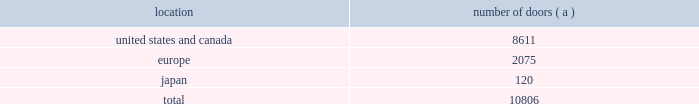Global brand concepts american living american living is the first brand developed under the newglobal brand concepts group .
American living is a full lifestyle brand , featuring menswear , womenswear , childrenswear , accessories and home furnishings with a focus on timeless , authentic american classics for every day .
American living is available exclusively at jcpenney in the u.s .
And online at jcp.com .
Our wholesale segment our wholesale segment sells our products to leading upscale and certain mid-tier department stores , specialty stores and golf and pro shops , both domestically and internationally .
We have focused on elevating our brand and improving productivity by reducing the number of unproductive doors within department stores in which our products are sold , improving in-store product assortment and presentation , and improving full-price sell-throughs to consumers .
As of march 29 , 2008 , the end of fiscal 2008 , our products were sold through 10806 doors worldwide , and during fiscal 2008 , we invested approximately $ 49 million in shop-within-shops dedicated to our products primarily in domestic and international department stores .
We have also effected selective price increases on basic products and introduced new fashion offerings at higher price points .
Department stores are our major wholesale customers in north america .
In europe , our wholesale sales are a varying mix of sales to both department stores and specialty shops , depending on the country .
Our collection brands 2014 women 2019s ralph lauren collection and black label and men 2019s purple label collection and black label 2014 are distributed through a limited number of premier fashion retailers .
In addition , we sell excess and out- of-season products through secondary distribution channels , including our retail factory stores .
In japan , our products are distributed primarily through shop-within-shops at premiere department stores .
The mix of business is weighted to polo ralph lauren inmen 2019s andwomen 2019s blue label .
The distribution of men 2019s and women 2019s black label is also expanding through shop-within-shop presentations in top tier department stores across japan .
Worldwide distribution channels the table presents the approximate number of doors by geographic location , in which products distributed by our wholesale segment were sold to consumers as of march 29 , 2008 : location number of doors ( a ) .
( a ) in asia/pacific ( excluding japan ) , our products are distributed by our licensing partners .
The following department store chains werewholesale customers whose purchases represented more than 10% ( 10 % ) of our worldwide wholesale net sales for the year ended march 29 , 2008 : 2022 macy 2019s , inc .
( formerly known as federated department stores , inc. ) , which represented approximately 24% ( 24 % ) ; and 2022 dillard department stores , inc. , which represented approximately 12% ( 12 % ) .
Our product brands are sold primarily through their own sales forces .
Our wholesale segment maintains their primary showrooms in new york city .
In addition , we maintain regional showrooms in atlanta , chicago , dallas , los angeles , milan , paris , london , munich , madrid and stockholm. .
What percentage of the wholesale segment as of march 29 , 2008 doors was in the united states and canada geography? 
Computations: (8611 / 10806)
Answer: 0.79687. 